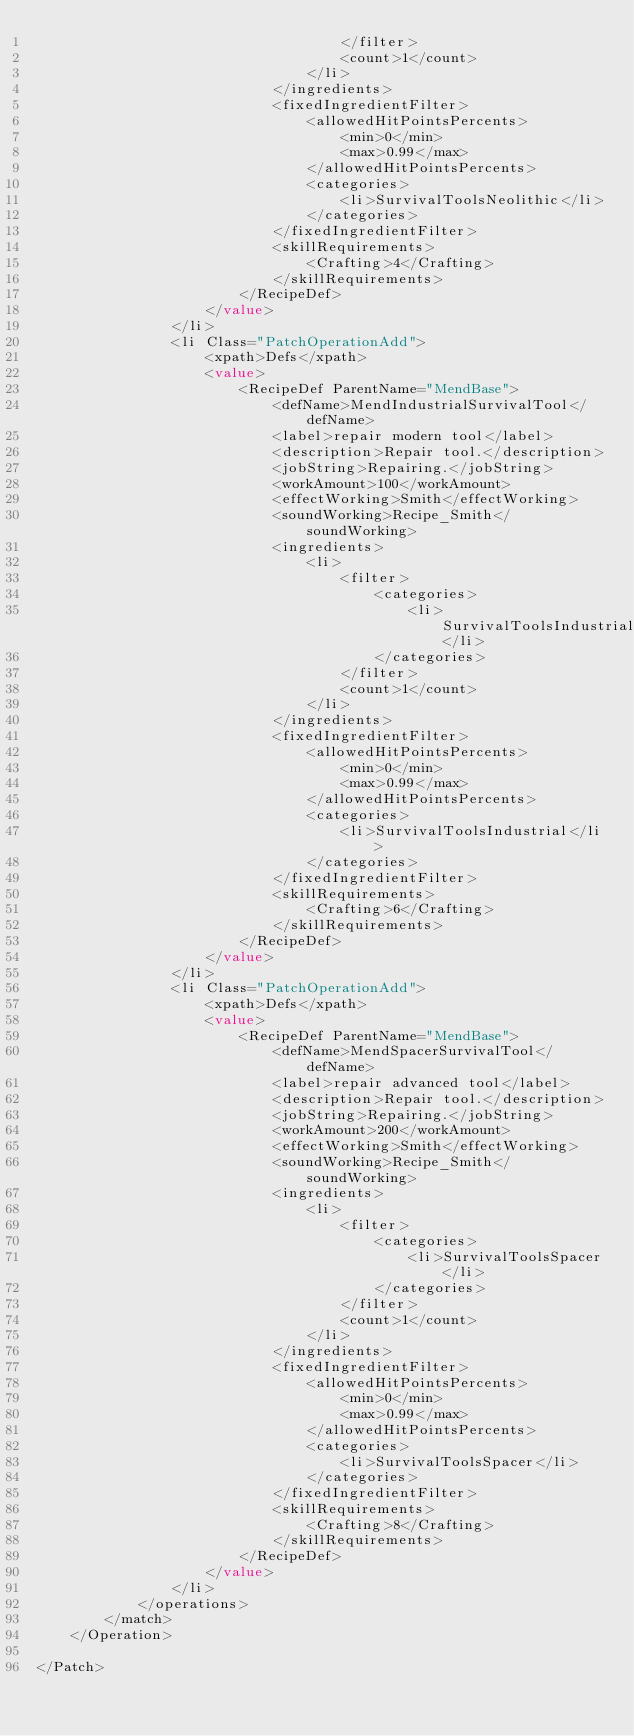Convert code to text. <code><loc_0><loc_0><loc_500><loc_500><_XML_>                                    </filter>
                                    <count>1</count>
                                </li>
                            </ingredients>
                            <fixedIngredientFilter>
                                <allowedHitPointsPercents>
                                    <min>0</min>
                                    <max>0.99</max>
                                </allowedHitPointsPercents>
                                <categories>
                                    <li>SurvivalToolsNeolithic</li>
                                </categories>
                            </fixedIngredientFilter>
                            <skillRequirements>
                                <Crafting>4</Crafting>
                            </skillRequirements>
                        </RecipeDef>
                    </value>
                </li>
                <li Class="PatchOperationAdd">
                    <xpath>Defs</xpath>
                    <value>
                        <RecipeDef ParentName="MendBase">
                            <defName>MendIndustrialSurvivalTool</defName>
                            <label>repair modern tool</label>
                            <description>Repair tool.</description>
                            <jobString>Repairing.</jobString>
                            <workAmount>100</workAmount>
                            <effectWorking>Smith</effectWorking>
                            <soundWorking>Recipe_Smith</soundWorking>
                            <ingredients>
                                <li>
                                    <filter>
                                        <categories>
                                            <li>SurvivalToolsIndustrial</li>
                                        </categories>
                                    </filter>
                                    <count>1</count>
                                </li>
                            </ingredients>
                            <fixedIngredientFilter>
                                <allowedHitPointsPercents>
                                    <min>0</min>
                                    <max>0.99</max>
                                </allowedHitPointsPercents>
                                <categories>
                                    <li>SurvivalToolsIndustrial</li>
                                </categories>
                            </fixedIngredientFilter>
                            <skillRequirements>
                                <Crafting>6</Crafting>
                            </skillRequirements>
                        </RecipeDef>
                    </value>
                </li>
                <li Class="PatchOperationAdd">
                    <xpath>Defs</xpath>
                    <value>
                        <RecipeDef ParentName="MendBase">
                            <defName>MendSpacerSurvivalTool</defName>
                            <label>repair advanced tool</label>
                            <description>Repair tool.</description>
                            <jobString>Repairing.</jobString>
                            <workAmount>200</workAmount>
                            <effectWorking>Smith</effectWorking>
                            <soundWorking>Recipe_Smith</soundWorking>
                            <ingredients>
                                <li>
                                    <filter>
                                        <categories>
                                            <li>SurvivalToolsSpacer</li>
                                        </categories>
                                    </filter>
                                    <count>1</count>
                                </li>
                            </ingredients>
                            <fixedIngredientFilter>
                                <allowedHitPointsPercents>
                                    <min>0</min>
                                    <max>0.99</max>
                                </allowedHitPointsPercents>
                                <categories>
                                    <li>SurvivalToolsSpacer</li>
                                </categories>
                            </fixedIngredientFilter>
                            <skillRequirements>
                                <Crafting>8</Crafting>
                            </skillRequirements>
                        </RecipeDef>
                    </value>
                </li>
            </operations>
        </match>
    </Operation>

</Patch></code> 